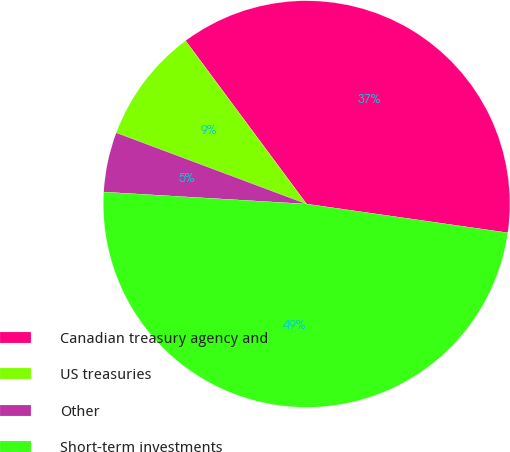Convert chart to OTSL. <chart><loc_0><loc_0><loc_500><loc_500><pie_chart><fcel>Canadian treasury agency and<fcel>US treasuries<fcel>Other<fcel>Short-term investments<nl><fcel>37.41%<fcel>9.15%<fcel>4.76%<fcel>48.68%<nl></chart> 